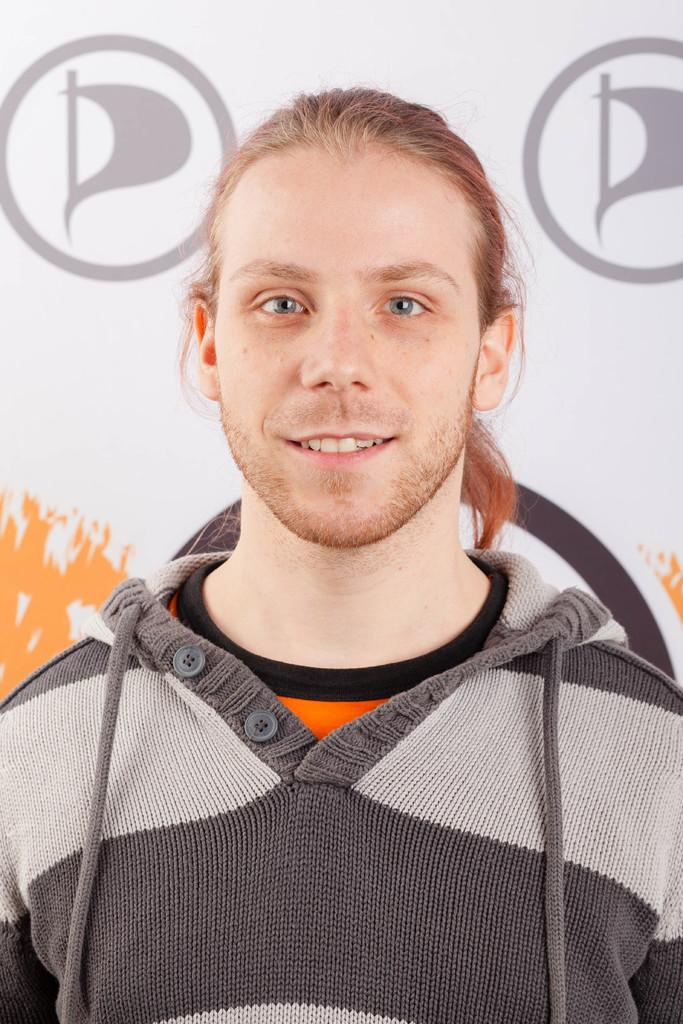Who or what is present in the image? There is a person in the image. What colors can be seen on the person's clothing? The person is wearing grey, orange, black, and ash colors. What can be seen in the background of the image? There is a banner in the background of the image. What type of jar is being used to hold the dress in the image? There is no jar or dress present in the image; it only features a person wearing specific colors and a banner in the background. 